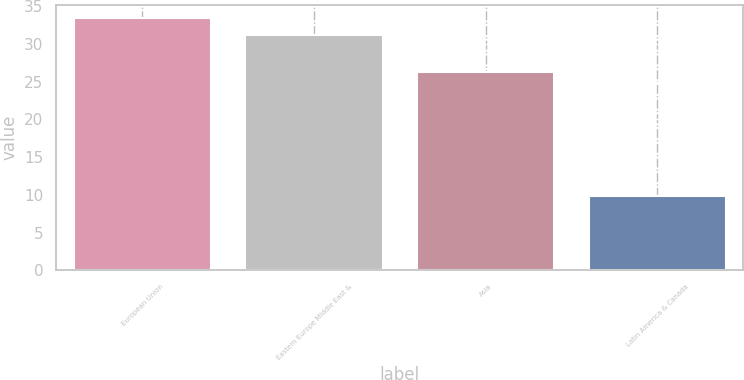<chart> <loc_0><loc_0><loc_500><loc_500><bar_chart><fcel>European Union<fcel>Eastern Europe Middle East &<fcel>Asia<fcel>Latin America & Canada<nl><fcel>33.47<fcel>31.2<fcel>26.3<fcel>9.9<nl></chart> 